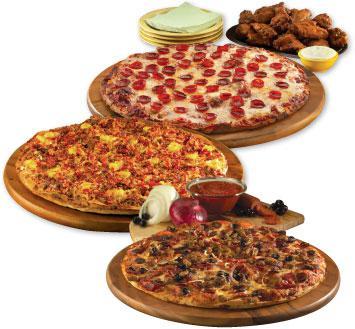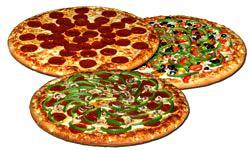The first image is the image on the left, the second image is the image on the right. Evaluate the accuracy of this statement regarding the images: "There is at least one uncut pizza.". Is it true? Answer yes or no. Yes. The first image is the image on the left, the second image is the image on the right. Assess this claim about the two images: "All the pizzas in these images are still whole circles and have not yet been cut into slices.". Correct or not? Answer yes or no. Yes. 